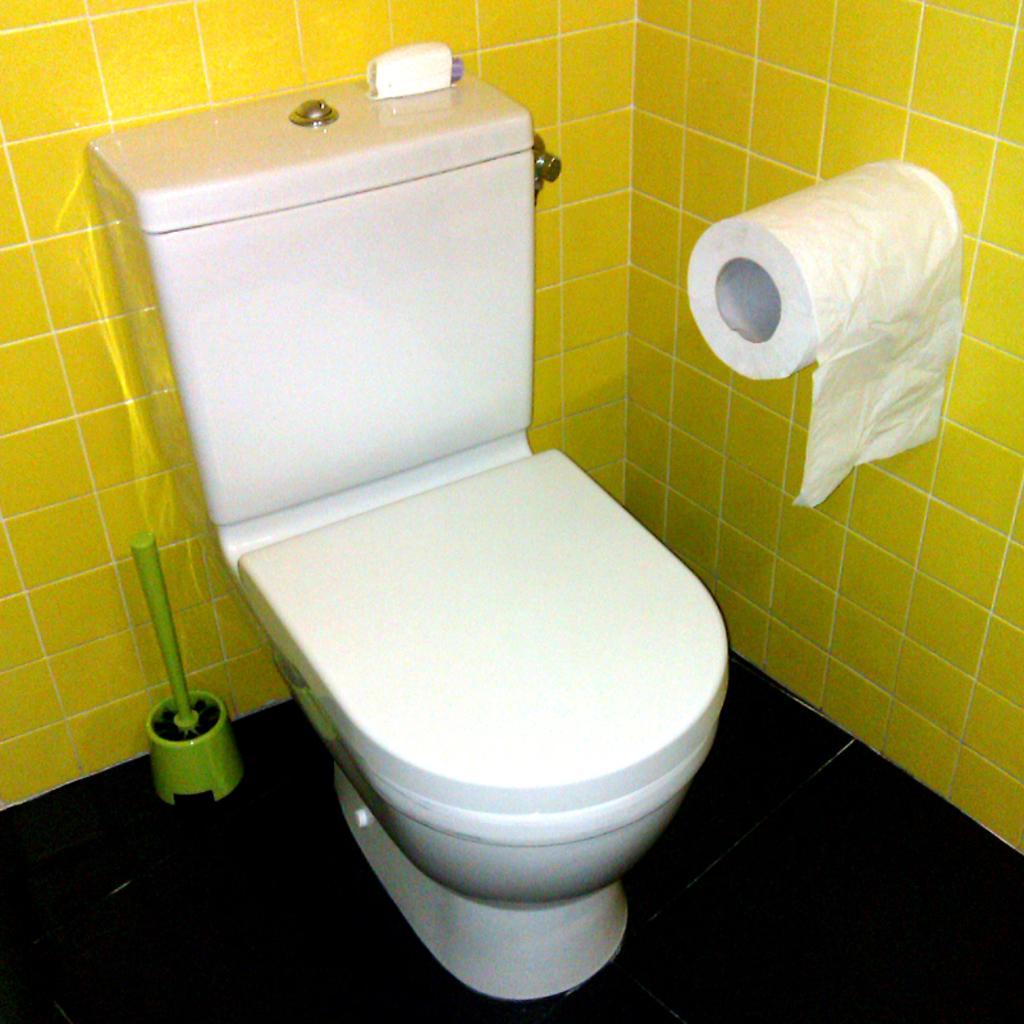How would you summarize this image in a sentence or two? In this image there is a toilet seat on the floor having an object on it. There is a flush tank having an object on it. Right side there is a tissue roll attached to the wall. 